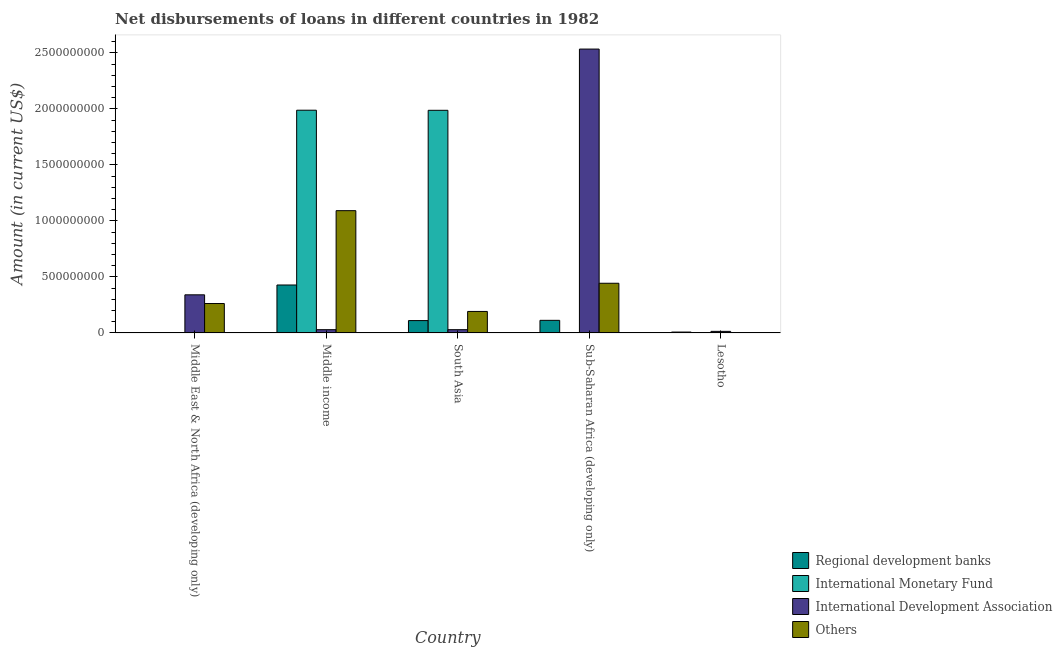How many groups of bars are there?
Ensure brevity in your answer.  5. Are the number of bars per tick equal to the number of legend labels?
Your answer should be very brief. No. What is the label of the 1st group of bars from the left?
Ensure brevity in your answer.  Middle East & North Africa (developing only). What is the amount of loan disimbursed by international development association in Middle East & North Africa (developing only)?
Ensure brevity in your answer.  3.40e+08. Across all countries, what is the maximum amount of loan disimbursed by international monetary fund?
Give a very brief answer. 1.99e+09. What is the total amount of loan disimbursed by international monetary fund in the graph?
Provide a short and direct response. 3.98e+09. What is the difference between the amount of loan disimbursed by regional development banks in Middle East & North Africa (developing only) and that in Middle income?
Your answer should be very brief. -4.26e+08. What is the difference between the amount of loan disimbursed by regional development banks in Lesotho and the amount of loan disimbursed by other organisations in Middle East & North Africa (developing only)?
Offer a terse response. -2.55e+08. What is the average amount of loan disimbursed by international development association per country?
Your response must be concise. 5.89e+08. What is the difference between the amount of loan disimbursed by international monetary fund and amount of loan disimbursed by international development association in South Asia?
Ensure brevity in your answer.  1.96e+09. What is the ratio of the amount of loan disimbursed by regional development banks in Middle East & North Africa (developing only) to that in South Asia?
Ensure brevity in your answer.  0.02. Is the amount of loan disimbursed by regional development banks in Middle East & North Africa (developing only) less than that in Middle income?
Keep it short and to the point. Yes. What is the difference between the highest and the second highest amount of loan disimbursed by international development association?
Provide a short and direct response. 2.19e+09. What is the difference between the highest and the lowest amount of loan disimbursed by international monetary fund?
Your response must be concise. 1.99e+09. In how many countries, is the amount of loan disimbursed by other organisations greater than the average amount of loan disimbursed by other organisations taken over all countries?
Offer a terse response. 2. Is it the case that in every country, the sum of the amount of loan disimbursed by regional development banks and amount of loan disimbursed by international monetary fund is greater than the amount of loan disimbursed by international development association?
Ensure brevity in your answer.  No. How many countries are there in the graph?
Provide a succinct answer. 5. Are the values on the major ticks of Y-axis written in scientific E-notation?
Your answer should be compact. No. How many legend labels are there?
Offer a terse response. 4. How are the legend labels stacked?
Your answer should be very brief. Vertical. What is the title of the graph?
Keep it short and to the point. Net disbursements of loans in different countries in 1982. Does "Fiscal policy" appear as one of the legend labels in the graph?
Give a very brief answer. No. What is the label or title of the X-axis?
Ensure brevity in your answer.  Country. What is the Amount (in current US$) of Regional development banks in Middle East & North Africa (developing only)?
Your answer should be compact. 2.32e+06. What is the Amount (in current US$) of International Development Association in Middle East & North Africa (developing only)?
Your response must be concise. 3.40e+08. What is the Amount (in current US$) of Others in Middle East & North Africa (developing only)?
Provide a succinct answer. 2.63e+08. What is the Amount (in current US$) of Regional development banks in Middle income?
Offer a terse response. 4.28e+08. What is the Amount (in current US$) of International Monetary Fund in Middle income?
Your response must be concise. 1.99e+09. What is the Amount (in current US$) in International Development Association in Middle income?
Provide a short and direct response. 2.91e+07. What is the Amount (in current US$) in Others in Middle income?
Offer a very short reply. 1.09e+09. What is the Amount (in current US$) of Regional development banks in South Asia?
Offer a terse response. 1.10e+08. What is the Amount (in current US$) in International Monetary Fund in South Asia?
Keep it short and to the point. 1.99e+09. What is the Amount (in current US$) of International Development Association in South Asia?
Keep it short and to the point. 2.91e+07. What is the Amount (in current US$) in Others in South Asia?
Your response must be concise. 1.92e+08. What is the Amount (in current US$) in Regional development banks in Sub-Saharan Africa (developing only)?
Ensure brevity in your answer.  1.12e+08. What is the Amount (in current US$) in International Monetary Fund in Sub-Saharan Africa (developing only)?
Make the answer very short. 0. What is the Amount (in current US$) of International Development Association in Sub-Saharan Africa (developing only)?
Give a very brief answer. 2.53e+09. What is the Amount (in current US$) of Others in Sub-Saharan Africa (developing only)?
Offer a terse response. 4.44e+08. What is the Amount (in current US$) in Regional development banks in Lesotho?
Offer a very short reply. 7.96e+06. What is the Amount (in current US$) in International Monetary Fund in Lesotho?
Provide a succinct answer. 0. What is the Amount (in current US$) of International Development Association in Lesotho?
Offer a very short reply. 1.41e+07. What is the Amount (in current US$) in Others in Lesotho?
Your answer should be compact. 3.25e+06. Across all countries, what is the maximum Amount (in current US$) in Regional development banks?
Ensure brevity in your answer.  4.28e+08. Across all countries, what is the maximum Amount (in current US$) of International Monetary Fund?
Ensure brevity in your answer.  1.99e+09. Across all countries, what is the maximum Amount (in current US$) in International Development Association?
Your answer should be compact. 2.53e+09. Across all countries, what is the maximum Amount (in current US$) in Others?
Keep it short and to the point. 1.09e+09. Across all countries, what is the minimum Amount (in current US$) of Regional development banks?
Your answer should be very brief. 2.32e+06. Across all countries, what is the minimum Amount (in current US$) of International Monetary Fund?
Your response must be concise. 0. Across all countries, what is the minimum Amount (in current US$) in International Development Association?
Make the answer very short. 1.41e+07. Across all countries, what is the minimum Amount (in current US$) in Others?
Ensure brevity in your answer.  3.25e+06. What is the total Amount (in current US$) of Regional development banks in the graph?
Provide a short and direct response. 6.61e+08. What is the total Amount (in current US$) in International Monetary Fund in the graph?
Your response must be concise. 3.98e+09. What is the total Amount (in current US$) in International Development Association in the graph?
Your answer should be compact. 2.95e+09. What is the total Amount (in current US$) of Others in the graph?
Your answer should be very brief. 1.99e+09. What is the difference between the Amount (in current US$) in Regional development banks in Middle East & North Africa (developing only) and that in Middle income?
Keep it short and to the point. -4.26e+08. What is the difference between the Amount (in current US$) of International Development Association in Middle East & North Africa (developing only) and that in Middle income?
Give a very brief answer. 3.11e+08. What is the difference between the Amount (in current US$) in Others in Middle East & North Africa (developing only) and that in Middle income?
Offer a terse response. -8.29e+08. What is the difference between the Amount (in current US$) in Regional development banks in Middle East & North Africa (developing only) and that in South Asia?
Provide a short and direct response. -1.08e+08. What is the difference between the Amount (in current US$) in International Development Association in Middle East & North Africa (developing only) and that in South Asia?
Offer a very short reply. 3.11e+08. What is the difference between the Amount (in current US$) in Others in Middle East & North Africa (developing only) and that in South Asia?
Your answer should be very brief. 7.07e+07. What is the difference between the Amount (in current US$) in Regional development banks in Middle East & North Africa (developing only) and that in Sub-Saharan Africa (developing only)?
Provide a short and direct response. -1.10e+08. What is the difference between the Amount (in current US$) in International Development Association in Middle East & North Africa (developing only) and that in Sub-Saharan Africa (developing only)?
Provide a short and direct response. -2.19e+09. What is the difference between the Amount (in current US$) of Others in Middle East & North Africa (developing only) and that in Sub-Saharan Africa (developing only)?
Your response must be concise. -1.81e+08. What is the difference between the Amount (in current US$) in Regional development banks in Middle East & North Africa (developing only) and that in Lesotho?
Offer a very short reply. -5.64e+06. What is the difference between the Amount (in current US$) of International Development Association in Middle East & North Africa (developing only) and that in Lesotho?
Offer a very short reply. 3.26e+08. What is the difference between the Amount (in current US$) of Others in Middle East & North Africa (developing only) and that in Lesotho?
Provide a short and direct response. 2.59e+08. What is the difference between the Amount (in current US$) in Regional development banks in Middle income and that in South Asia?
Make the answer very short. 3.18e+08. What is the difference between the Amount (in current US$) of International Monetary Fund in Middle income and that in South Asia?
Keep it short and to the point. 9.31e+05. What is the difference between the Amount (in current US$) in International Development Association in Middle income and that in South Asia?
Your answer should be very brief. 0. What is the difference between the Amount (in current US$) of Others in Middle income and that in South Asia?
Your response must be concise. 9.00e+08. What is the difference between the Amount (in current US$) of Regional development banks in Middle income and that in Sub-Saharan Africa (developing only)?
Your answer should be compact. 3.16e+08. What is the difference between the Amount (in current US$) in International Development Association in Middle income and that in Sub-Saharan Africa (developing only)?
Give a very brief answer. -2.51e+09. What is the difference between the Amount (in current US$) in Others in Middle income and that in Sub-Saharan Africa (developing only)?
Make the answer very short. 6.48e+08. What is the difference between the Amount (in current US$) in Regional development banks in Middle income and that in Lesotho?
Offer a very short reply. 4.20e+08. What is the difference between the Amount (in current US$) in International Development Association in Middle income and that in Lesotho?
Your response must be concise. 1.50e+07. What is the difference between the Amount (in current US$) of Others in Middle income and that in Lesotho?
Keep it short and to the point. 1.09e+09. What is the difference between the Amount (in current US$) of Regional development banks in South Asia and that in Sub-Saharan Africa (developing only)?
Provide a succinct answer. -2.15e+06. What is the difference between the Amount (in current US$) of International Development Association in South Asia and that in Sub-Saharan Africa (developing only)?
Provide a short and direct response. -2.51e+09. What is the difference between the Amount (in current US$) of Others in South Asia and that in Sub-Saharan Africa (developing only)?
Provide a short and direct response. -2.52e+08. What is the difference between the Amount (in current US$) of Regional development banks in South Asia and that in Lesotho?
Your answer should be compact. 1.02e+08. What is the difference between the Amount (in current US$) of International Development Association in South Asia and that in Lesotho?
Your answer should be compact. 1.50e+07. What is the difference between the Amount (in current US$) of Others in South Asia and that in Lesotho?
Your answer should be compact. 1.89e+08. What is the difference between the Amount (in current US$) in Regional development banks in Sub-Saharan Africa (developing only) and that in Lesotho?
Keep it short and to the point. 1.05e+08. What is the difference between the Amount (in current US$) in International Development Association in Sub-Saharan Africa (developing only) and that in Lesotho?
Your answer should be compact. 2.52e+09. What is the difference between the Amount (in current US$) in Others in Sub-Saharan Africa (developing only) and that in Lesotho?
Your answer should be compact. 4.40e+08. What is the difference between the Amount (in current US$) in Regional development banks in Middle East & North Africa (developing only) and the Amount (in current US$) in International Monetary Fund in Middle income?
Give a very brief answer. -1.99e+09. What is the difference between the Amount (in current US$) of Regional development banks in Middle East & North Africa (developing only) and the Amount (in current US$) of International Development Association in Middle income?
Your answer should be compact. -2.68e+07. What is the difference between the Amount (in current US$) in Regional development banks in Middle East & North Africa (developing only) and the Amount (in current US$) in Others in Middle income?
Your answer should be compact. -1.09e+09. What is the difference between the Amount (in current US$) of International Development Association in Middle East & North Africa (developing only) and the Amount (in current US$) of Others in Middle income?
Provide a short and direct response. -7.51e+08. What is the difference between the Amount (in current US$) of Regional development banks in Middle East & North Africa (developing only) and the Amount (in current US$) of International Monetary Fund in South Asia?
Your response must be concise. -1.99e+09. What is the difference between the Amount (in current US$) of Regional development banks in Middle East & North Africa (developing only) and the Amount (in current US$) of International Development Association in South Asia?
Provide a succinct answer. -2.68e+07. What is the difference between the Amount (in current US$) of Regional development banks in Middle East & North Africa (developing only) and the Amount (in current US$) of Others in South Asia?
Keep it short and to the point. -1.90e+08. What is the difference between the Amount (in current US$) in International Development Association in Middle East & North Africa (developing only) and the Amount (in current US$) in Others in South Asia?
Give a very brief answer. 1.48e+08. What is the difference between the Amount (in current US$) in Regional development banks in Middle East & North Africa (developing only) and the Amount (in current US$) in International Development Association in Sub-Saharan Africa (developing only)?
Keep it short and to the point. -2.53e+09. What is the difference between the Amount (in current US$) in Regional development banks in Middle East & North Africa (developing only) and the Amount (in current US$) in Others in Sub-Saharan Africa (developing only)?
Your answer should be compact. -4.41e+08. What is the difference between the Amount (in current US$) in International Development Association in Middle East & North Africa (developing only) and the Amount (in current US$) in Others in Sub-Saharan Africa (developing only)?
Provide a succinct answer. -1.03e+08. What is the difference between the Amount (in current US$) of Regional development banks in Middle East & North Africa (developing only) and the Amount (in current US$) of International Development Association in Lesotho?
Provide a short and direct response. -1.18e+07. What is the difference between the Amount (in current US$) in Regional development banks in Middle East & North Africa (developing only) and the Amount (in current US$) in Others in Lesotho?
Offer a terse response. -9.31e+05. What is the difference between the Amount (in current US$) of International Development Association in Middle East & North Africa (developing only) and the Amount (in current US$) of Others in Lesotho?
Ensure brevity in your answer.  3.37e+08. What is the difference between the Amount (in current US$) in Regional development banks in Middle income and the Amount (in current US$) in International Monetary Fund in South Asia?
Ensure brevity in your answer.  -1.56e+09. What is the difference between the Amount (in current US$) in Regional development banks in Middle income and the Amount (in current US$) in International Development Association in South Asia?
Offer a very short reply. 3.99e+08. What is the difference between the Amount (in current US$) of Regional development banks in Middle income and the Amount (in current US$) of Others in South Asia?
Provide a short and direct response. 2.36e+08. What is the difference between the Amount (in current US$) of International Monetary Fund in Middle income and the Amount (in current US$) of International Development Association in South Asia?
Your response must be concise. 1.96e+09. What is the difference between the Amount (in current US$) in International Monetary Fund in Middle income and the Amount (in current US$) in Others in South Asia?
Your answer should be compact. 1.80e+09. What is the difference between the Amount (in current US$) in International Development Association in Middle income and the Amount (in current US$) in Others in South Asia?
Give a very brief answer. -1.63e+08. What is the difference between the Amount (in current US$) in Regional development banks in Middle income and the Amount (in current US$) in International Development Association in Sub-Saharan Africa (developing only)?
Provide a succinct answer. -2.11e+09. What is the difference between the Amount (in current US$) of Regional development banks in Middle income and the Amount (in current US$) of Others in Sub-Saharan Africa (developing only)?
Your answer should be compact. -1.55e+07. What is the difference between the Amount (in current US$) in International Monetary Fund in Middle income and the Amount (in current US$) in International Development Association in Sub-Saharan Africa (developing only)?
Your answer should be compact. -5.46e+08. What is the difference between the Amount (in current US$) in International Monetary Fund in Middle income and the Amount (in current US$) in Others in Sub-Saharan Africa (developing only)?
Make the answer very short. 1.54e+09. What is the difference between the Amount (in current US$) of International Development Association in Middle income and the Amount (in current US$) of Others in Sub-Saharan Africa (developing only)?
Give a very brief answer. -4.14e+08. What is the difference between the Amount (in current US$) of Regional development banks in Middle income and the Amount (in current US$) of International Development Association in Lesotho?
Provide a succinct answer. 4.14e+08. What is the difference between the Amount (in current US$) of Regional development banks in Middle income and the Amount (in current US$) of Others in Lesotho?
Give a very brief answer. 4.25e+08. What is the difference between the Amount (in current US$) of International Monetary Fund in Middle income and the Amount (in current US$) of International Development Association in Lesotho?
Provide a short and direct response. 1.97e+09. What is the difference between the Amount (in current US$) in International Monetary Fund in Middle income and the Amount (in current US$) in Others in Lesotho?
Ensure brevity in your answer.  1.99e+09. What is the difference between the Amount (in current US$) of International Development Association in Middle income and the Amount (in current US$) of Others in Lesotho?
Ensure brevity in your answer.  2.59e+07. What is the difference between the Amount (in current US$) of Regional development banks in South Asia and the Amount (in current US$) of International Development Association in Sub-Saharan Africa (developing only)?
Give a very brief answer. -2.42e+09. What is the difference between the Amount (in current US$) in Regional development banks in South Asia and the Amount (in current US$) in Others in Sub-Saharan Africa (developing only)?
Offer a terse response. -3.33e+08. What is the difference between the Amount (in current US$) in International Monetary Fund in South Asia and the Amount (in current US$) in International Development Association in Sub-Saharan Africa (developing only)?
Provide a succinct answer. -5.47e+08. What is the difference between the Amount (in current US$) in International Monetary Fund in South Asia and the Amount (in current US$) in Others in Sub-Saharan Africa (developing only)?
Offer a very short reply. 1.54e+09. What is the difference between the Amount (in current US$) in International Development Association in South Asia and the Amount (in current US$) in Others in Sub-Saharan Africa (developing only)?
Your response must be concise. -4.14e+08. What is the difference between the Amount (in current US$) of Regional development banks in South Asia and the Amount (in current US$) of International Development Association in Lesotho?
Give a very brief answer. 9.62e+07. What is the difference between the Amount (in current US$) in Regional development banks in South Asia and the Amount (in current US$) in Others in Lesotho?
Give a very brief answer. 1.07e+08. What is the difference between the Amount (in current US$) of International Monetary Fund in South Asia and the Amount (in current US$) of International Development Association in Lesotho?
Make the answer very short. 1.97e+09. What is the difference between the Amount (in current US$) of International Monetary Fund in South Asia and the Amount (in current US$) of Others in Lesotho?
Give a very brief answer. 1.98e+09. What is the difference between the Amount (in current US$) of International Development Association in South Asia and the Amount (in current US$) of Others in Lesotho?
Ensure brevity in your answer.  2.59e+07. What is the difference between the Amount (in current US$) in Regional development banks in Sub-Saharan Africa (developing only) and the Amount (in current US$) in International Development Association in Lesotho?
Provide a short and direct response. 9.84e+07. What is the difference between the Amount (in current US$) in Regional development banks in Sub-Saharan Africa (developing only) and the Amount (in current US$) in Others in Lesotho?
Provide a short and direct response. 1.09e+08. What is the difference between the Amount (in current US$) in International Development Association in Sub-Saharan Africa (developing only) and the Amount (in current US$) in Others in Lesotho?
Give a very brief answer. 2.53e+09. What is the average Amount (in current US$) in Regional development banks per country?
Keep it short and to the point. 1.32e+08. What is the average Amount (in current US$) of International Monetary Fund per country?
Offer a very short reply. 7.95e+08. What is the average Amount (in current US$) of International Development Association per country?
Offer a very short reply. 5.89e+08. What is the average Amount (in current US$) in Others per country?
Give a very brief answer. 3.99e+08. What is the difference between the Amount (in current US$) in Regional development banks and Amount (in current US$) in International Development Association in Middle East & North Africa (developing only)?
Provide a succinct answer. -3.38e+08. What is the difference between the Amount (in current US$) in Regional development banks and Amount (in current US$) in Others in Middle East & North Africa (developing only)?
Give a very brief answer. -2.60e+08. What is the difference between the Amount (in current US$) in International Development Association and Amount (in current US$) in Others in Middle East & North Africa (developing only)?
Your response must be concise. 7.77e+07. What is the difference between the Amount (in current US$) in Regional development banks and Amount (in current US$) in International Monetary Fund in Middle income?
Keep it short and to the point. -1.56e+09. What is the difference between the Amount (in current US$) of Regional development banks and Amount (in current US$) of International Development Association in Middle income?
Give a very brief answer. 3.99e+08. What is the difference between the Amount (in current US$) in Regional development banks and Amount (in current US$) in Others in Middle income?
Make the answer very short. -6.64e+08. What is the difference between the Amount (in current US$) in International Monetary Fund and Amount (in current US$) in International Development Association in Middle income?
Offer a very short reply. 1.96e+09. What is the difference between the Amount (in current US$) of International Monetary Fund and Amount (in current US$) of Others in Middle income?
Your answer should be compact. 8.97e+08. What is the difference between the Amount (in current US$) in International Development Association and Amount (in current US$) in Others in Middle income?
Provide a succinct answer. -1.06e+09. What is the difference between the Amount (in current US$) of Regional development banks and Amount (in current US$) of International Monetary Fund in South Asia?
Your response must be concise. -1.88e+09. What is the difference between the Amount (in current US$) in Regional development banks and Amount (in current US$) in International Development Association in South Asia?
Keep it short and to the point. 8.12e+07. What is the difference between the Amount (in current US$) in Regional development banks and Amount (in current US$) in Others in South Asia?
Make the answer very short. -8.16e+07. What is the difference between the Amount (in current US$) in International Monetary Fund and Amount (in current US$) in International Development Association in South Asia?
Provide a short and direct response. 1.96e+09. What is the difference between the Amount (in current US$) in International Monetary Fund and Amount (in current US$) in Others in South Asia?
Your answer should be compact. 1.80e+09. What is the difference between the Amount (in current US$) of International Development Association and Amount (in current US$) of Others in South Asia?
Keep it short and to the point. -1.63e+08. What is the difference between the Amount (in current US$) of Regional development banks and Amount (in current US$) of International Development Association in Sub-Saharan Africa (developing only)?
Ensure brevity in your answer.  -2.42e+09. What is the difference between the Amount (in current US$) in Regional development banks and Amount (in current US$) in Others in Sub-Saharan Africa (developing only)?
Provide a succinct answer. -3.31e+08. What is the difference between the Amount (in current US$) in International Development Association and Amount (in current US$) in Others in Sub-Saharan Africa (developing only)?
Your response must be concise. 2.09e+09. What is the difference between the Amount (in current US$) of Regional development banks and Amount (in current US$) of International Development Association in Lesotho?
Provide a succinct answer. -6.13e+06. What is the difference between the Amount (in current US$) in Regional development banks and Amount (in current US$) in Others in Lesotho?
Keep it short and to the point. 4.71e+06. What is the difference between the Amount (in current US$) of International Development Association and Amount (in current US$) of Others in Lesotho?
Your answer should be compact. 1.08e+07. What is the ratio of the Amount (in current US$) in Regional development banks in Middle East & North Africa (developing only) to that in Middle income?
Your response must be concise. 0.01. What is the ratio of the Amount (in current US$) of International Development Association in Middle East & North Africa (developing only) to that in Middle income?
Make the answer very short. 11.69. What is the ratio of the Amount (in current US$) in Others in Middle East & North Africa (developing only) to that in Middle income?
Give a very brief answer. 0.24. What is the ratio of the Amount (in current US$) of Regional development banks in Middle East & North Africa (developing only) to that in South Asia?
Keep it short and to the point. 0.02. What is the ratio of the Amount (in current US$) in International Development Association in Middle East & North Africa (developing only) to that in South Asia?
Your answer should be very brief. 11.69. What is the ratio of the Amount (in current US$) in Others in Middle East & North Africa (developing only) to that in South Asia?
Ensure brevity in your answer.  1.37. What is the ratio of the Amount (in current US$) of Regional development banks in Middle East & North Africa (developing only) to that in Sub-Saharan Africa (developing only)?
Provide a short and direct response. 0.02. What is the ratio of the Amount (in current US$) in International Development Association in Middle East & North Africa (developing only) to that in Sub-Saharan Africa (developing only)?
Your response must be concise. 0.13. What is the ratio of the Amount (in current US$) of Others in Middle East & North Africa (developing only) to that in Sub-Saharan Africa (developing only)?
Provide a succinct answer. 0.59. What is the ratio of the Amount (in current US$) of Regional development banks in Middle East & North Africa (developing only) to that in Lesotho?
Your answer should be compact. 0.29. What is the ratio of the Amount (in current US$) in International Development Association in Middle East & North Africa (developing only) to that in Lesotho?
Your answer should be compact. 24.15. What is the ratio of the Amount (in current US$) in Others in Middle East & North Africa (developing only) to that in Lesotho?
Offer a very short reply. 80.83. What is the ratio of the Amount (in current US$) in Regional development banks in Middle income to that in South Asia?
Provide a short and direct response. 3.88. What is the ratio of the Amount (in current US$) of Others in Middle income to that in South Asia?
Your response must be concise. 5.69. What is the ratio of the Amount (in current US$) in Regional development banks in Middle income to that in Sub-Saharan Africa (developing only)?
Keep it short and to the point. 3.81. What is the ratio of the Amount (in current US$) in International Development Association in Middle income to that in Sub-Saharan Africa (developing only)?
Provide a short and direct response. 0.01. What is the ratio of the Amount (in current US$) of Others in Middle income to that in Sub-Saharan Africa (developing only)?
Your answer should be very brief. 2.46. What is the ratio of the Amount (in current US$) in Regional development banks in Middle income to that in Lesotho?
Your response must be concise. 53.8. What is the ratio of the Amount (in current US$) of International Development Association in Middle income to that in Lesotho?
Your answer should be compact. 2.07. What is the ratio of the Amount (in current US$) in Others in Middle income to that in Lesotho?
Give a very brief answer. 335.98. What is the ratio of the Amount (in current US$) in Regional development banks in South Asia to that in Sub-Saharan Africa (developing only)?
Your response must be concise. 0.98. What is the ratio of the Amount (in current US$) of International Development Association in South Asia to that in Sub-Saharan Africa (developing only)?
Your response must be concise. 0.01. What is the ratio of the Amount (in current US$) of Others in South Asia to that in Sub-Saharan Africa (developing only)?
Keep it short and to the point. 0.43. What is the ratio of the Amount (in current US$) in Regional development banks in South Asia to that in Lesotho?
Your response must be concise. 13.87. What is the ratio of the Amount (in current US$) in International Development Association in South Asia to that in Lesotho?
Make the answer very short. 2.07. What is the ratio of the Amount (in current US$) of Others in South Asia to that in Lesotho?
Make the answer very short. 59.07. What is the ratio of the Amount (in current US$) of Regional development banks in Sub-Saharan Africa (developing only) to that in Lesotho?
Provide a succinct answer. 14.14. What is the ratio of the Amount (in current US$) in International Development Association in Sub-Saharan Africa (developing only) to that in Lesotho?
Your answer should be compact. 179.85. What is the ratio of the Amount (in current US$) in Others in Sub-Saharan Africa (developing only) to that in Lesotho?
Make the answer very short. 136.53. What is the difference between the highest and the second highest Amount (in current US$) of Regional development banks?
Make the answer very short. 3.16e+08. What is the difference between the highest and the second highest Amount (in current US$) in International Development Association?
Ensure brevity in your answer.  2.19e+09. What is the difference between the highest and the second highest Amount (in current US$) of Others?
Offer a very short reply. 6.48e+08. What is the difference between the highest and the lowest Amount (in current US$) in Regional development banks?
Provide a succinct answer. 4.26e+08. What is the difference between the highest and the lowest Amount (in current US$) in International Monetary Fund?
Provide a short and direct response. 1.99e+09. What is the difference between the highest and the lowest Amount (in current US$) in International Development Association?
Your answer should be very brief. 2.52e+09. What is the difference between the highest and the lowest Amount (in current US$) in Others?
Keep it short and to the point. 1.09e+09. 